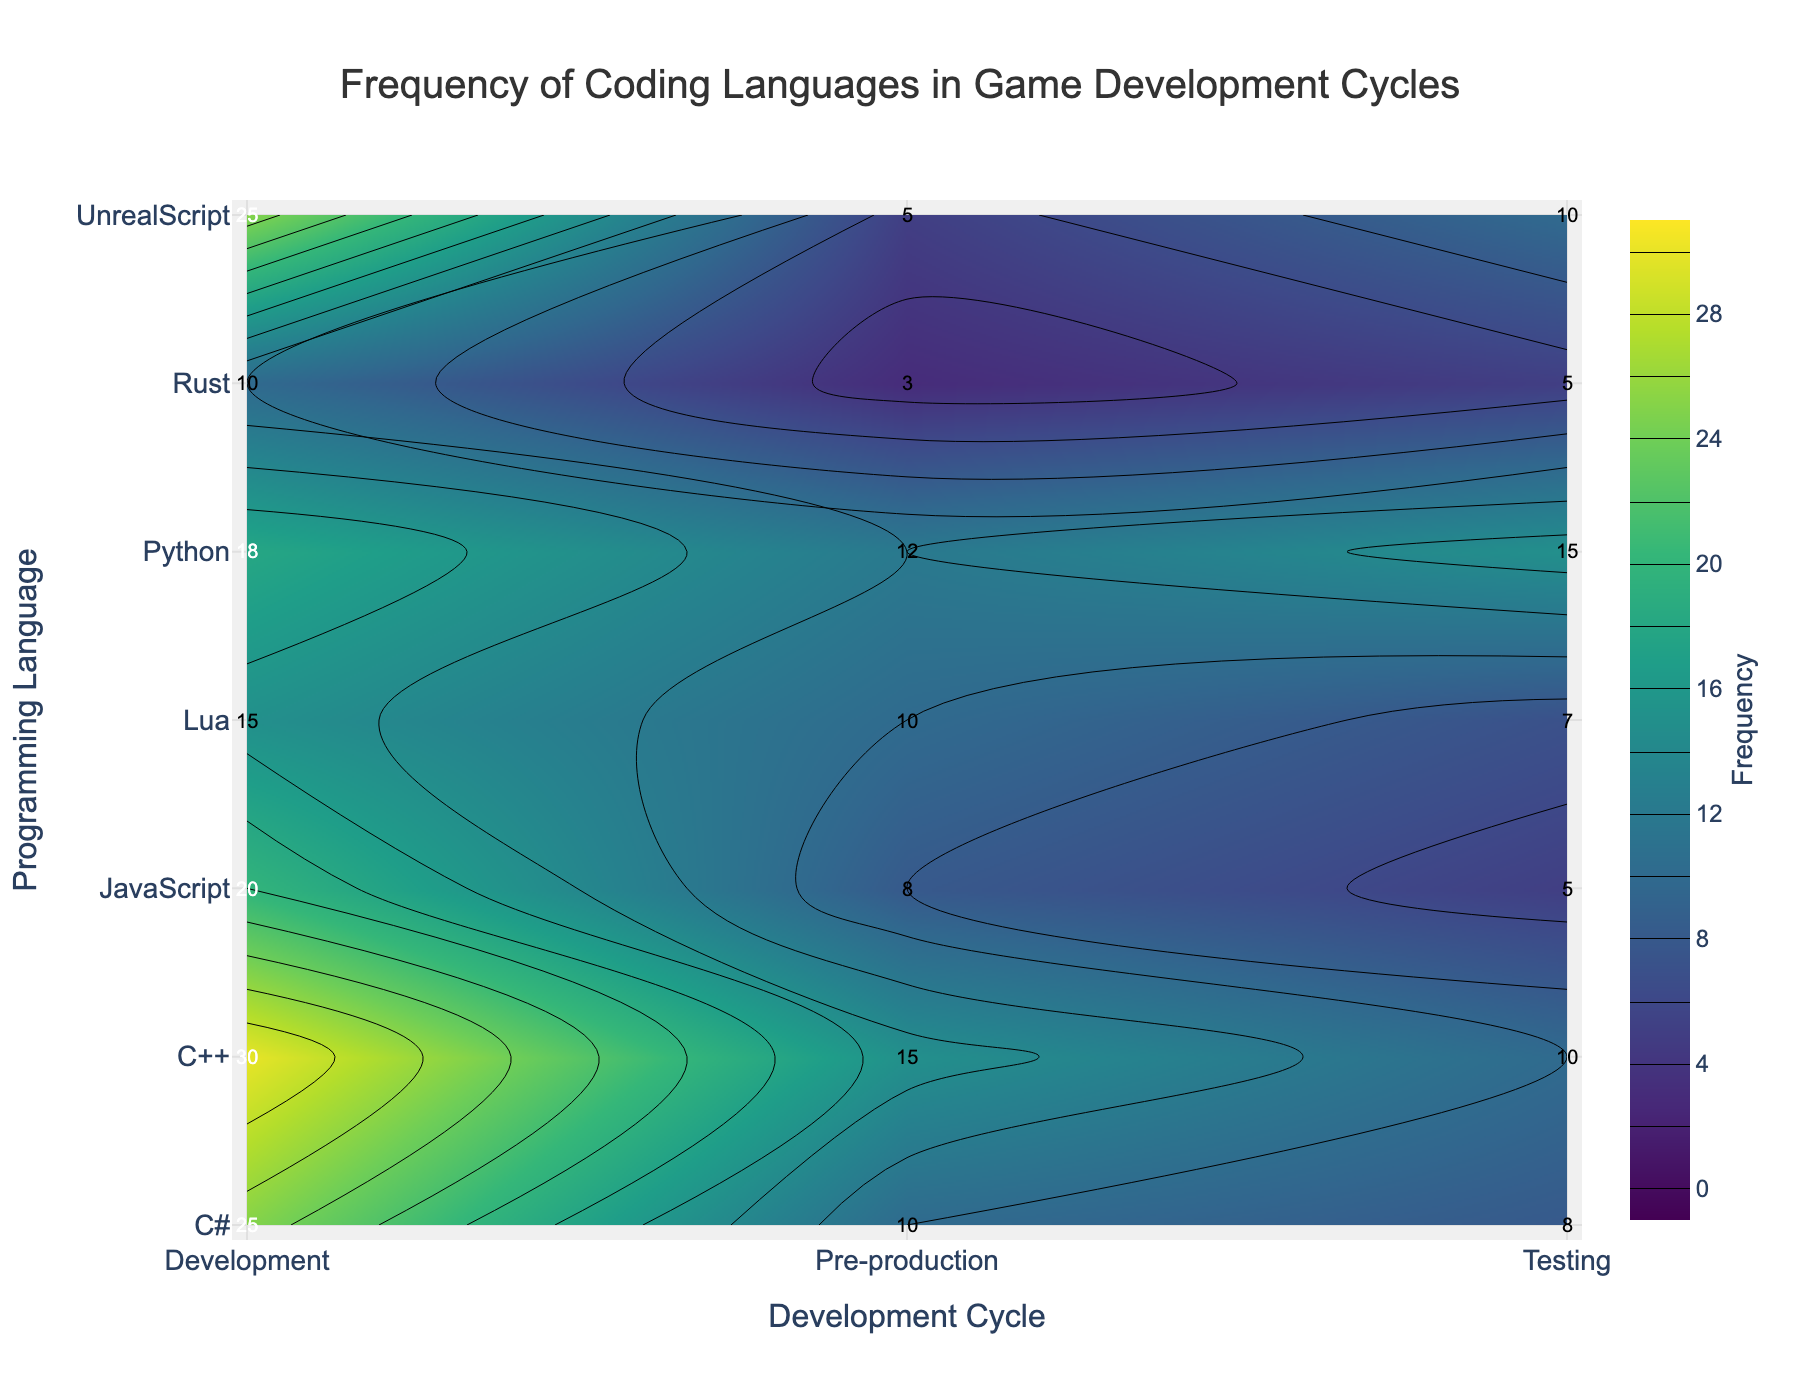How many data points represent the 'Development' cycle? The 'Development' cycle appears on the x-axis, and each programming language has a data point for it. Counting them gives us 7 languages: C++, C#, Python, JavaScript, UnrealScript, Lua, and Rust.
Answer: 7 Which programming language has the highest frequency during the 'Development' cycle? By examining the 'Development' cycle on the x-axis and looking at the contours and labels, the maximum frequency observed is 30 for C++.
Answer: C++ What is the average frequency of C# across all cycles? The frequencies for C# are 10 in 'Pre-production', 25 in 'Development', and 8 in 'Testing'. Adding them gives 43, and dividing by the number of cycles (3) gives the average, 43/3 = 14.33
Answer: 14.33 Which cycle has the lowest overall usage of programming languages? To determine this, sum the frequencies in each cycle. 'Pre-production': 15+10+12+8+5+10+3=63, 'Development': 30+25+18+20+25+15+10=143, 'Testing': 10+8+15+5+10+7+5=60. 'Testing' has the lowest total.
Answer: Testing Between Python and Lua, which programming language is used more in the 'Testing' cycle? Comparing the frequencies in the 'Testing' cycle for both, Python has 15 and Lua has 7. Hence, Python is used more.
Answer: Python What is the difference in frequency between C++ and Rust during the 'Development' cycle? C++ has a frequency of 30 and Rust has 10 in the 'Development' cycle. The difference is 30 - 10 = 20.
Answer: 20 Identify the programming language with the smallest change in frequency across all cycles. By looking at the differences between cycles for each language: C++ (15 to 30 to 10), C# (10 to 25 to 8), Python (12 to 18 to 15), JavaScript (8 to 20 to 5), UnrealScript (5 to 25 to 10), Lua (10 to 15 to 7), Rust (3 to 10 to 5). Rust has the smallest change.
Answer: Rust In the 'Pre-production' cycle, which programming language has a frequency closest to the median value of that cycle? The sorted list of frequencies in 'Pre-production': 3, 5, 8, 10, 10, 12, 15. The median value is 10. Both C# and Lua have frequencies of 10, which are closest.
Answer: C# and Lua 